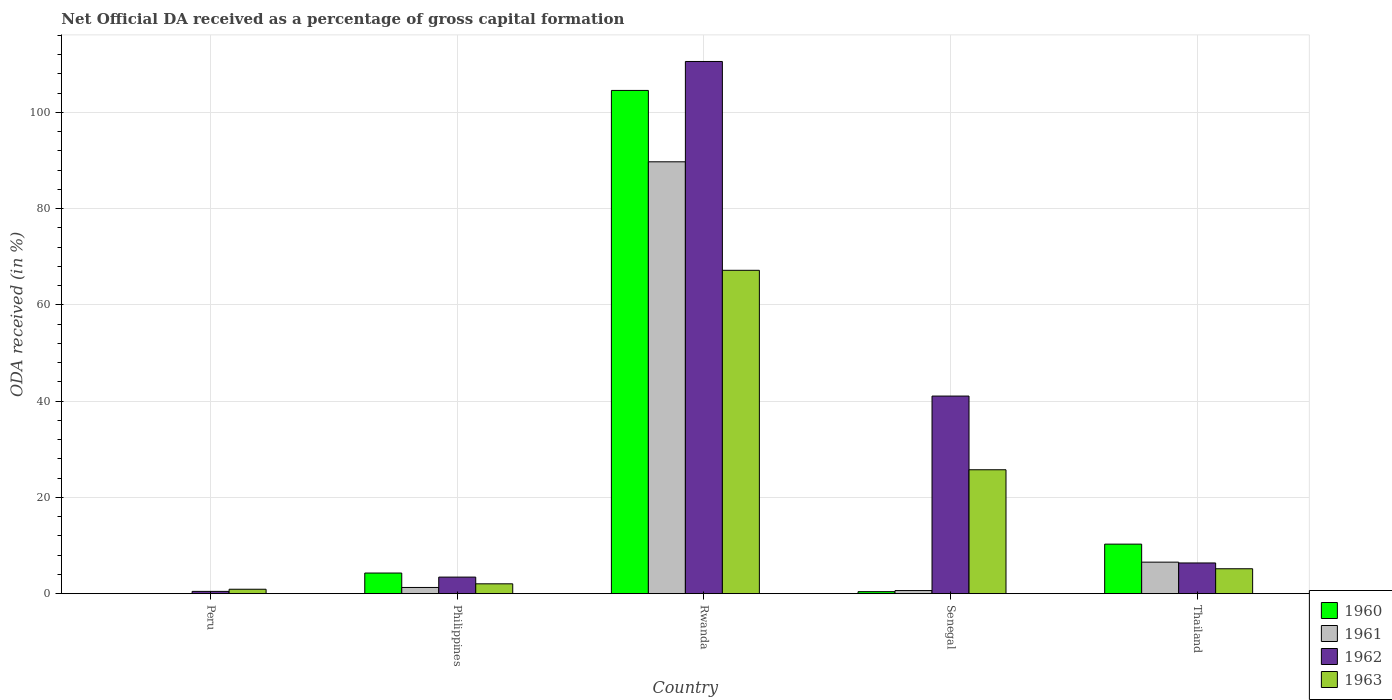How many groups of bars are there?
Offer a terse response. 5. Are the number of bars on each tick of the X-axis equal?
Ensure brevity in your answer.  No. What is the label of the 5th group of bars from the left?
Offer a very short reply. Thailand. In how many cases, is the number of bars for a given country not equal to the number of legend labels?
Give a very brief answer. 1. What is the net ODA received in 1960 in Philippines?
Offer a very short reply. 4.28. Across all countries, what is the maximum net ODA received in 1963?
Your answer should be very brief. 67.2. Across all countries, what is the minimum net ODA received in 1960?
Provide a short and direct response. 0. In which country was the net ODA received in 1960 maximum?
Offer a terse response. Rwanda. What is the total net ODA received in 1961 in the graph?
Keep it short and to the point. 98.23. What is the difference between the net ODA received in 1962 in Philippines and that in Thailand?
Provide a short and direct response. -2.94. What is the difference between the net ODA received in 1962 in Philippines and the net ODA received in 1963 in Rwanda?
Your answer should be very brief. -63.76. What is the average net ODA received in 1962 per country?
Make the answer very short. 32.39. What is the difference between the net ODA received of/in 1963 and net ODA received of/in 1961 in Senegal?
Offer a very short reply. 25.11. What is the ratio of the net ODA received in 1963 in Peru to that in Philippines?
Offer a terse response. 0.45. Is the difference between the net ODA received in 1963 in Philippines and Rwanda greater than the difference between the net ODA received in 1961 in Philippines and Rwanda?
Give a very brief answer. Yes. What is the difference between the highest and the second highest net ODA received in 1961?
Offer a very short reply. -88.46. What is the difference between the highest and the lowest net ODA received in 1960?
Offer a very short reply. 104.58. Is the sum of the net ODA received in 1963 in Philippines and Rwanda greater than the maximum net ODA received in 1960 across all countries?
Provide a succinct answer. No. Is it the case that in every country, the sum of the net ODA received in 1961 and net ODA received in 1962 is greater than the sum of net ODA received in 1963 and net ODA received in 1960?
Provide a short and direct response. No. Are all the bars in the graph horizontal?
Your answer should be compact. No. How many countries are there in the graph?
Make the answer very short. 5. Are the values on the major ticks of Y-axis written in scientific E-notation?
Provide a succinct answer. No. Does the graph contain any zero values?
Make the answer very short. Yes. Where does the legend appear in the graph?
Offer a very short reply. Bottom right. How many legend labels are there?
Offer a terse response. 4. What is the title of the graph?
Provide a short and direct response. Net Official DA received as a percentage of gross capital formation. Does "1986" appear as one of the legend labels in the graph?
Keep it short and to the point. No. What is the label or title of the X-axis?
Offer a very short reply. Country. What is the label or title of the Y-axis?
Your answer should be compact. ODA received (in %). What is the ODA received (in %) of 1961 in Peru?
Provide a succinct answer. 0. What is the ODA received (in %) in 1962 in Peru?
Provide a succinct answer. 0.47. What is the ODA received (in %) in 1963 in Peru?
Ensure brevity in your answer.  0.92. What is the ODA received (in %) of 1960 in Philippines?
Your answer should be very brief. 4.28. What is the ODA received (in %) of 1961 in Philippines?
Your answer should be compact. 1.29. What is the ODA received (in %) of 1962 in Philippines?
Make the answer very short. 3.44. What is the ODA received (in %) of 1963 in Philippines?
Your response must be concise. 2.05. What is the ODA received (in %) of 1960 in Rwanda?
Offer a terse response. 104.58. What is the ODA received (in %) in 1961 in Rwanda?
Provide a short and direct response. 89.75. What is the ODA received (in %) in 1962 in Rwanda?
Keep it short and to the point. 110.6. What is the ODA received (in %) in 1963 in Rwanda?
Offer a very short reply. 67.2. What is the ODA received (in %) in 1960 in Senegal?
Your response must be concise. 0.42. What is the ODA received (in %) of 1961 in Senegal?
Offer a terse response. 0.65. What is the ODA received (in %) in 1962 in Senegal?
Your response must be concise. 41.06. What is the ODA received (in %) in 1963 in Senegal?
Keep it short and to the point. 25.75. What is the ODA received (in %) of 1960 in Thailand?
Provide a succinct answer. 10.29. What is the ODA received (in %) of 1961 in Thailand?
Provide a short and direct response. 6.55. What is the ODA received (in %) of 1962 in Thailand?
Offer a very short reply. 6.38. What is the ODA received (in %) in 1963 in Thailand?
Provide a succinct answer. 5.18. Across all countries, what is the maximum ODA received (in %) of 1960?
Offer a very short reply. 104.58. Across all countries, what is the maximum ODA received (in %) of 1961?
Give a very brief answer. 89.75. Across all countries, what is the maximum ODA received (in %) of 1962?
Give a very brief answer. 110.6. Across all countries, what is the maximum ODA received (in %) in 1963?
Provide a succinct answer. 67.2. Across all countries, what is the minimum ODA received (in %) in 1960?
Offer a very short reply. 0. Across all countries, what is the minimum ODA received (in %) of 1961?
Offer a very short reply. 0. Across all countries, what is the minimum ODA received (in %) of 1962?
Provide a short and direct response. 0.47. Across all countries, what is the minimum ODA received (in %) of 1963?
Your answer should be very brief. 0.92. What is the total ODA received (in %) in 1960 in the graph?
Your response must be concise. 119.58. What is the total ODA received (in %) in 1961 in the graph?
Provide a short and direct response. 98.23. What is the total ODA received (in %) of 1962 in the graph?
Keep it short and to the point. 161.96. What is the total ODA received (in %) in 1963 in the graph?
Make the answer very short. 101.09. What is the difference between the ODA received (in %) of 1962 in Peru and that in Philippines?
Offer a very short reply. -2.97. What is the difference between the ODA received (in %) of 1963 in Peru and that in Philippines?
Keep it short and to the point. -1.13. What is the difference between the ODA received (in %) of 1962 in Peru and that in Rwanda?
Keep it short and to the point. -110.13. What is the difference between the ODA received (in %) of 1963 in Peru and that in Rwanda?
Make the answer very short. -66.28. What is the difference between the ODA received (in %) of 1962 in Peru and that in Senegal?
Make the answer very short. -40.59. What is the difference between the ODA received (in %) in 1963 in Peru and that in Senegal?
Offer a very short reply. -24.83. What is the difference between the ODA received (in %) of 1962 in Peru and that in Thailand?
Offer a terse response. -5.91. What is the difference between the ODA received (in %) of 1963 in Peru and that in Thailand?
Offer a terse response. -4.26. What is the difference between the ODA received (in %) in 1960 in Philippines and that in Rwanda?
Give a very brief answer. -100.3. What is the difference between the ODA received (in %) of 1961 in Philippines and that in Rwanda?
Provide a short and direct response. -88.46. What is the difference between the ODA received (in %) of 1962 in Philippines and that in Rwanda?
Your answer should be compact. -107.16. What is the difference between the ODA received (in %) of 1963 in Philippines and that in Rwanda?
Make the answer very short. -65.15. What is the difference between the ODA received (in %) of 1960 in Philippines and that in Senegal?
Give a very brief answer. 3.87. What is the difference between the ODA received (in %) of 1961 in Philippines and that in Senegal?
Offer a terse response. 0.64. What is the difference between the ODA received (in %) in 1962 in Philippines and that in Senegal?
Offer a terse response. -37.62. What is the difference between the ODA received (in %) of 1963 in Philippines and that in Senegal?
Offer a terse response. -23.7. What is the difference between the ODA received (in %) in 1960 in Philippines and that in Thailand?
Offer a very short reply. -6.01. What is the difference between the ODA received (in %) in 1961 in Philippines and that in Thailand?
Make the answer very short. -5.26. What is the difference between the ODA received (in %) in 1962 in Philippines and that in Thailand?
Your answer should be compact. -2.94. What is the difference between the ODA received (in %) of 1963 in Philippines and that in Thailand?
Make the answer very short. -3.13. What is the difference between the ODA received (in %) in 1960 in Rwanda and that in Senegal?
Keep it short and to the point. 104.17. What is the difference between the ODA received (in %) in 1961 in Rwanda and that in Senegal?
Your response must be concise. 89.1. What is the difference between the ODA received (in %) in 1962 in Rwanda and that in Senegal?
Offer a terse response. 69.54. What is the difference between the ODA received (in %) in 1963 in Rwanda and that in Senegal?
Provide a short and direct response. 41.45. What is the difference between the ODA received (in %) of 1960 in Rwanda and that in Thailand?
Offer a terse response. 94.29. What is the difference between the ODA received (in %) in 1961 in Rwanda and that in Thailand?
Make the answer very short. 83.2. What is the difference between the ODA received (in %) of 1962 in Rwanda and that in Thailand?
Provide a succinct answer. 104.22. What is the difference between the ODA received (in %) of 1963 in Rwanda and that in Thailand?
Make the answer very short. 62.02. What is the difference between the ODA received (in %) of 1960 in Senegal and that in Thailand?
Give a very brief answer. -9.88. What is the difference between the ODA received (in %) in 1961 in Senegal and that in Thailand?
Your response must be concise. -5.91. What is the difference between the ODA received (in %) of 1962 in Senegal and that in Thailand?
Make the answer very short. 34.68. What is the difference between the ODA received (in %) in 1963 in Senegal and that in Thailand?
Your answer should be very brief. 20.57. What is the difference between the ODA received (in %) in 1962 in Peru and the ODA received (in %) in 1963 in Philippines?
Make the answer very short. -1.57. What is the difference between the ODA received (in %) of 1962 in Peru and the ODA received (in %) of 1963 in Rwanda?
Give a very brief answer. -66.73. What is the difference between the ODA received (in %) in 1962 in Peru and the ODA received (in %) in 1963 in Senegal?
Offer a very short reply. -25.28. What is the difference between the ODA received (in %) in 1962 in Peru and the ODA received (in %) in 1963 in Thailand?
Ensure brevity in your answer.  -4.7. What is the difference between the ODA received (in %) of 1960 in Philippines and the ODA received (in %) of 1961 in Rwanda?
Give a very brief answer. -85.47. What is the difference between the ODA received (in %) of 1960 in Philippines and the ODA received (in %) of 1962 in Rwanda?
Your response must be concise. -106.32. What is the difference between the ODA received (in %) in 1960 in Philippines and the ODA received (in %) in 1963 in Rwanda?
Offer a terse response. -62.92. What is the difference between the ODA received (in %) in 1961 in Philippines and the ODA received (in %) in 1962 in Rwanda?
Offer a terse response. -109.31. What is the difference between the ODA received (in %) in 1961 in Philippines and the ODA received (in %) in 1963 in Rwanda?
Keep it short and to the point. -65.91. What is the difference between the ODA received (in %) in 1962 in Philippines and the ODA received (in %) in 1963 in Rwanda?
Offer a terse response. -63.76. What is the difference between the ODA received (in %) of 1960 in Philippines and the ODA received (in %) of 1961 in Senegal?
Offer a terse response. 3.64. What is the difference between the ODA received (in %) of 1960 in Philippines and the ODA received (in %) of 1962 in Senegal?
Make the answer very short. -36.78. What is the difference between the ODA received (in %) in 1960 in Philippines and the ODA received (in %) in 1963 in Senegal?
Your response must be concise. -21.47. What is the difference between the ODA received (in %) in 1961 in Philippines and the ODA received (in %) in 1962 in Senegal?
Ensure brevity in your answer.  -39.78. What is the difference between the ODA received (in %) in 1961 in Philippines and the ODA received (in %) in 1963 in Senegal?
Ensure brevity in your answer.  -24.46. What is the difference between the ODA received (in %) in 1962 in Philippines and the ODA received (in %) in 1963 in Senegal?
Provide a short and direct response. -22.31. What is the difference between the ODA received (in %) in 1960 in Philippines and the ODA received (in %) in 1961 in Thailand?
Give a very brief answer. -2.27. What is the difference between the ODA received (in %) of 1960 in Philippines and the ODA received (in %) of 1962 in Thailand?
Your answer should be compact. -2.1. What is the difference between the ODA received (in %) of 1960 in Philippines and the ODA received (in %) of 1963 in Thailand?
Offer a very short reply. -0.89. What is the difference between the ODA received (in %) in 1961 in Philippines and the ODA received (in %) in 1962 in Thailand?
Give a very brief answer. -5.09. What is the difference between the ODA received (in %) in 1961 in Philippines and the ODA received (in %) in 1963 in Thailand?
Your response must be concise. -3.89. What is the difference between the ODA received (in %) of 1962 in Philippines and the ODA received (in %) of 1963 in Thailand?
Provide a succinct answer. -1.73. What is the difference between the ODA received (in %) in 1960 in Rwanda and the ODA received (in %) in 1961 in Senegal?
Offer a terse response. 103.94. What is the difference between the ODA received (in %) of 1960 in Rwanda and the ODA received (in %) of 1962 in Senegal?
Offer a terse response. 63.52. What is the difference between the ODA received (in %) in 1960 in Rwanda and the ODA received (in %) in 1963 in Senegal?
Your answer should be compact. 78.83. What is the difference between the ODA received (in %) in 1961 in Rwanda and the ODA received (in %) in 1962 in Senegal?
Provide a short and direct response. 48.69. What is the difference between the ODA received (in %) of 1961 in Rwanda and the ODA received (in %) of 1963 in Senegal?
Your answer should be very brief. 64. What is the difference between the ODA received (in %) in 1962 in Rwanda and the ODA received (in %) in 1963 in Senegal?
Offer a terse response. 84.85. What is the difference between the ODA received (in %) of 1960 in Rwanda and the ODA received (in %) of 1961 in Thailand?
Make the answer very short. 98.03. What is the difference between the ODA received (in %) of 1960 in Rwanda and the ODA received (in %) of 1962 in Thailand?
Your answer should be very brief. 98.2. What is the difference between the ODA received (in %) in 1960 in Rwanda and the ODA received (in %) in 1963 in Thailand?
Provide a succinct answer. 99.41. What is the difference between the ODA received (in %) in 1961 in Rwanda and the ODA received (in %) in 1962 in Thailand?
Keep it short and to the point. 83.37. What is the difference between the ODA received (in %) in 1961 in Rwanda and the ODA received (in %) in 1963 in Thailand?
Give a very brief answer. 84.57. What is the difference between the ODA received (in %) in 1962 in Rwanda and the ODA received (in %) in 1963 in Thailand?
Your answer should be very brief. 105.42. What is the difference between the ODA received (in %) of 1960 in Senegal and the ODA received (in %) of 1961 in Thailand?
Keep it short and to the point. -6.13. What is the difference between the ODA received (in %) in 1960 in Senegal and the ODA received (in %) in 1962 in Thailand?
Offer a very short reply. -5.96. What is the difference between the ODA received (in %) of 1960 in Senegal and the ODA received (in %) of 1963 in Thailand?
Keep it short and to the point. -4.76. What is the difference between the ODA received (in %) in 1961 in Senegal and the ODA received (in %) in 1962 in Thailand?
Make the answer very short. -5.73. What is the difference between the ODA received (in %) of 1961 in Senegal and the ODA received (in %) of 1963 in Thailand?
Your answer should be compact. -4.53. What is the difference between the ODA received (in %) of 1962 in Senegal and the ODA received (in %) of 1963 in Thailand?
Offer a terse response. 35.89. What is the average ODA received (in %) of 1960 per country?
Your answer should be very brief. 23.92. What is the average ODA received (in %) of 1961 per country?
Offer a very short reply. 19.65. What is the average ODA received (in %) of 1962 per country?
Your answer should be very brief. 32.39. What is the average ODA received (in %) in 1963 per country?
Give a very brief answer. 20.22. What is the difference between the ODA received (in %) in 1962 and ODA received (in %) in 1963 in Peru?
Offer a terse response. -0.44. What is the difference between the ODA received (in %) in 1960 and ODA received (in %) in 1961 in Philippines?
Your response must be concise. 3. What is the difference between the ODA received (in %) in 1960 and ODA received (in %) in 1962 in Philippines?
Give a very brief answer. 0.84. What is the difference between the ODA received (in %) in 1960 and ODA received (in %) in 1963 in Philippines?
Provide a succinct answer. 2.24. What is the difference between the ODA received (in %) of 1961 and ODA received (in %) of 1962 in Philippines?
Keep it short and to the point. -2.15. What is the difference between the ODA received (in %) in 1961 and ODA received (in %) in 1963 in Philippines?
Offer a very short reply. -0.76. What is the difference between the ODA received (in %) in 1962 and ODA received (in %) in 1963 in Philippines?
Ensure brevity in your answer.  1.4. What is the difference between the ODA received (in %) of 1960 and ODA received (in %) of 1961 in Rwanda?
Keep it short and to the point. 14.83. What is the difference between the ODA received (in %) of 1960 and ODA received (in %) of 1962 in Rwanda?
Offer a very short reply. -6.02. What is the difference between the ODA received (in %) in 1960 and ODA received (in %) in 1963 in Rwanda?
Give a very brief answer. 37.38. What is the difference between the ODA received (in %) of 1961 and ODA received (in %) of 1962 in Rwanda?
Your response must be concise. -20.85. What is the difference between the ODA received (in %) of 1961 and ODA received (in %) of 1963 in Rwanda?
Your answer should be compact. 22.55. What is the difference between the ODA received (in %) of 1962 and ODA received (in %) of 1963 in Rwanda?
Offer a terse response. 43.4. What is the difference between the ODA received (in %) of 1960 and ODA received (in %) of 1961 in Senegal?
Provide a succinct answer. -0.23. What is the difference between the ODA received (in %) in 1960 and ODA received (in %) in 1962 in Senegal?
Your response must be concise. -40.65. What is the difference between the ODA received (in %) of 1960 and ODA received (in %) of 1963 in Senegal?
Keep it short and to the point. -25.33. What is the difference between the ODA received (in %) in 1961 and ODA received (in %) in 1962 in Senegal?
Ensure brevity in your answer.  -40.42. What is the difference between the ODA received (in %) of 1961 and ODA received (in %) of 1963 in Senegal?
Ensure brevity in your answer.  -25.11. What is the difference between the ODA received (in %) in 1962 and ODA received (in %) in 1963 in Senegal?
Provide a succinct answer. 15.31. What is the difference between the ODA received (in %) in 1960 and ODA received (in %) in 1961 in Thailand?
Your answer should be compact. 3.74. What is the difference between the ODA received (in %) in 1960 and ODA received (in %) in 1962 in Thailand?
Keep it short and to the point. 3.91. What is the difference between the ODA received (in %) in 1960 and ODA received (in %) in 1963 in Thailand?
Offer a terse response. 5.12. What is the difference between the ODA received (in %) in 1961 and ODA received (in %) in 1962 in Thailand?
Your answer should be very brief. 0.17. What is the difference between the ODA received (in %) in 1961 and ODA received (in %) in 1963 in Thailand?
Offer a terse response. 1.37. What is the difference between the ODA received (in %) in 1962 and ODA received (in %) in 1963 in Thailand?
Your answer should be compact. 1.2. What is the ratio of the ODA received (in %) in 1962 in Peru to that in Philippines?
Offer a very short reply. 0.14. What is the ratio of the ODA received (in %) in 1963 in Peru to that in Philippines?
Your answer should be very brief. 0.45. What is the ratio of the ODA received (in %) of 1962 in Peru to that in Rwanda?
Make the answer very short. 0. What is the ratio of the ODA received (in %) in 1963 in Peru to that in Rwanda?
Provide a short and direct response. 0.01. What is the ratio of the ODA received (in %) of 1962 in Peru to that in Senegal?
Your answer should be compact. 0.01. What is the ratio of the ODA received (in %) in 1963 in Peru to that in Senegal?
Offer a terse response. 0.04. What is the ratio of the ODA received (in %) of 1962 in Peru to that in Thailand?
Provide a short and direct response. 0.07. What is the ratio of the ODA received (in %) of 1963 in Peru to that in Thailand?
Offer a very short reply. 0.18. What is the ratio of the ODA received (in %) of 1960 in Philippines to that in Rwanda?
Your response must be concise. 0.04. What is the ratio of the ODA received (in %) in 1961 in Philippines to that in Rwanda?
Make the answer very short. 0.01. What is the ratio of the ODA received (in %) of 1962 in Philippines to that in Rwanda?
Ensure brevity in your answer.  0.03. What is the ratio of the ODA received (in %) of 1963 in Philippines to that in Rwanda?
Your response must be concise. 0.03. What is the ratio of the ODA received (in %) of 1960 in Philippines to that in Senegal?
Provide a succinct answer. 10.3. What is the ratio of the ODA received (in %) in 1961 in Philippines to that in Senegal?
Make the answer very short. 2. What is the ratio of the ODA received (in %) in 1962 in Philippines to that in Senegal?
Make the answer very short. 0.08. What is the ratio of the ODA received (in %) in 1963 in Philippines to that in Senegal?
Your answer should be very brief. 0.08. What is the ratio of the ODA received (in %) in 1960 in Philippines to that in Thailand?
Give a very brief answer. 0.42. What is the ratio of the ODA received (in %) of 1961 in Philippines to that in Thailand?
Make the answer very short. 0.2. What is the ratio of the ODA received (in %) in 1962 in Philippines to that in Thailand?
Your answer should be compact. 0.54. What is the ratio of the ODA received (in %) of 1963 in Philippines to that in Thailand?
Your answer should be compact. 0.4. What is the ratio of the ODA received (in %) of 1960 in Rwanda to that in Senegal?
Make the answer very short. 251.36. What is the ratio of the ODA received (in %) in 1961 in Rwanda to that in Senegal?
Your answer should be very brief. 139.13. What is the ratio of the ODA received (in %) in 1962 in Rwanda to that in Senegal?
Ensure brevity in your answer.  2.69. What is the ratio of the ODA received (in %) of 1963 in Rwanda to that in Senegal?
Give a very brief answer. 2.61. What is the ratio of the ODA received (in %) in 1960 in Rwanda to that in Thailand?
Your answer should be very brief. 10.16. What is the ratio of the ODA received (in %) of 1961 in Rwanda to that in Thailand?
Provide a succinct answer. 13.7. What is the ratio of the ODA received (in %) of 1962 in Rwanda to that in Thailand?
Provide a succinct answer. 17.34. What is the ratio of the ODA received (in %) of 1963 in Rwanda to that in Thailand?
Your answer should be very brief. 12.98. What is the ratio of the ODA received (in %) of 1960 in Senegal to that in Thailand?
Ensure brevity in your answer.  0.04. What is the ratio of the ODA received (in %) in 1961 in Senegal to that in Thailand?
Your response must be concise. 0.1. What is the ratio of the ODA received (in %) in 1962 in Senegal to that in Thailand?
Ensure brevity in your answer.  6.44. What is the ratio of the ODA received (in %) of 1963 in Senegal to that in Thailand?
Keep it short and to the point. 4.97. What is the difference between the highest and the second highest ODA received (in %) in 1960?
Keep it short and to the point. 94.29. What is the difference between the highest and the second highest ODA received (in %) in 1961?
Offer a terse response. 83.2. What is the difference between the highest and the second highest ODA received (in %) in 1962?
Keep it short and to the point. 69.54. What is the difference between the highest and the second highest ODA received (in %) of 1963?
Make the answer very short. 41.45. What is the difference between the highest and the lowest ODA received (in %) in 1960?
Give a very brief answer. 104.58. What is the difference between the highest and the lowest ODA received (in %) in 1961?
Offer a very short reply. 89.75. What is the difference between the highest and the lowest ODA received (in %) of 1962?
Provide a short and direct response. 110.13. What is the difference between the highest and the lowest ODA received (in %) in 1963?
Offer a very short reply. 66.28. 